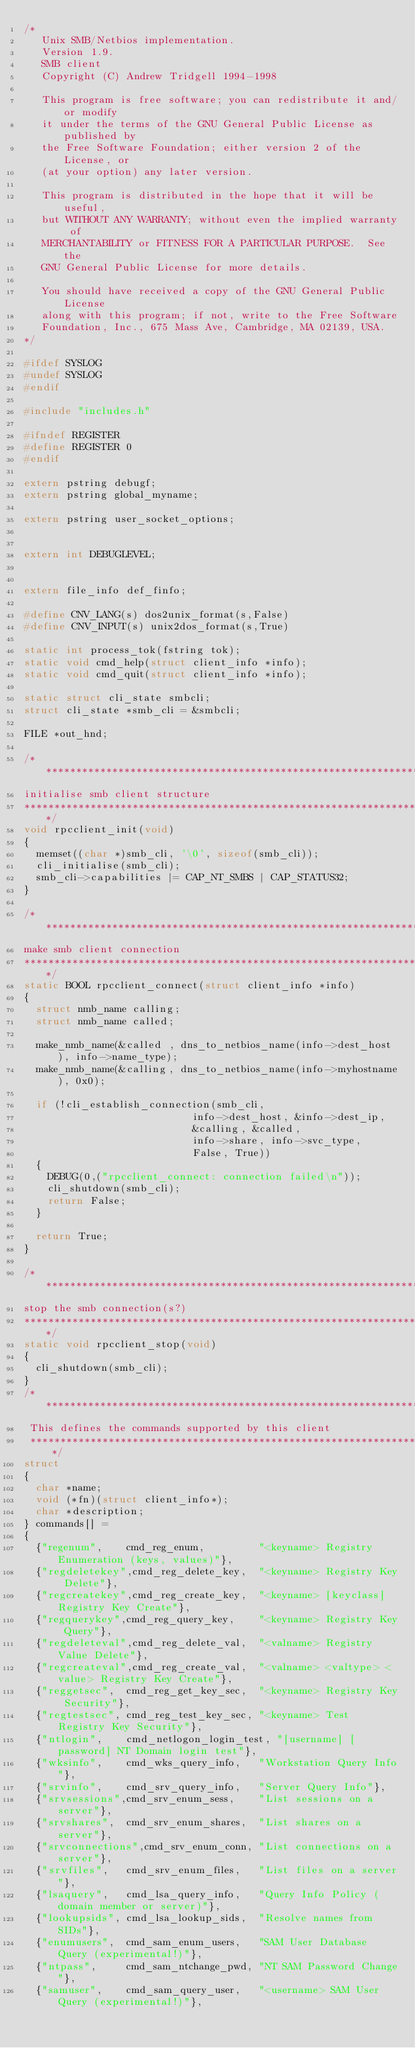<code> <loc_0><loc_0><loc_500><loc_500><_C_>/* 
   Unix SMB/Netbios implementation.
   Version 1.9.
   SMB client
   Copyright (C) Andrew Tridgell 1994-1998
   
   This program is free software; you can redistribute it and/or modify
   it under the terms of the GNU General Public License as published by
   the Free Software Foundation; either version 2 of the License, or
   (at your option) any later version.
   
   This program is distributed in the hope that it will be useful,
   but WITHOUT ANY WARRANTY; without even the implied warranty of
   MERCHANTABILITY or FITNESS FOR A PARTICULAR PURPOSE.  See the
   GNU General Public License for more details.
   
   You should have received a copy of the GNU General Public License
   along with this program; if not, write to the Free Software
   Foundation, Inc., 675 Mass Ave, Cambridge, MA 02139, USA.
*/

#ifdef SYSLOG
#undef SYSLOG
#endif

#include "includes.h"

#ifndef REGISTER
#define REGISTER 0
#endif

extern pstring debugf;
extern pstring global_myname;

extern pstring user_socket_options;


extern int DEBUGLEVEL;


extern file_info def_finfo;

#define CNV_LANG(s) dos2unix_format(s,False)
#define CNV_INPUT(s) unix2dos_format(s,True)

static int process_tok(fstring tok);
static void cmd_help(struct client_info *info);
static void cmd_quit(struct client_info *info);

static struct cli_state smbcli;
struct cli_state *smb_cli = &smbcli;

FILE *out_hnd;

/****************************************************************************
initialise smb client structure
****************************************************************************/
void rpcclient_init(void)
{
	memset((char *)smb_cli, '\0', sizeof(smb_cli));
	cli_initialise(smb_cli);
	smb_cli->capabilities |= CAP_NT_SMBS | CAP_STATUS32;
}

/****************************************************************************
make smb client connection
****************************************************************************/
static BOOL rpcclient_connect(struct client_info *info)
{
	struct nmb_name calling;
	struct nmb_name called;

	make_nmb_name(&called , dns_to_netbios_name(info->dest_host ), info->name_type);
	make_nmb_name(&calling, dns_to_netbios_name(info->myhostname), 0x0);

	if (!cli_establish_connection(smb_cli, 
	                          info->dest_host, &info->dest_ip, 
	                          &calling, &called,
	                          info->share, info->svc_type,
	                          False, True))
	{
		DEBUG(0,("rpcclient_connect: connection failed\n"));
		cli_shutdown(smb_cli);
		return False;
	}

	return True;
}

/****************************************************************************
stop the smb connection(s?)
****************************************************************************/
static void rpcclient_stop(void)
{
	cli_shutdown(smb_cli);
}
/****************************************************************************
 This defines the commands supported by this client
 ****************************************************************************/
struct
{
  char *name;
  void (*fn)(struct client_info*);
  char *description;
} commands[] = 
{
  {"regenum",    cmd_reg_enum,         "<keyname> Registry Enumeration (keys, values)"},
  {"regdeletekey",cmd_reg_delete_key,  "<keyname> Registry Key Delete"},
  {"regcreatekey",cmd_reg_create_key,  "<keyname> [keyclass] Registry Key Create"},
  {"regquerykey",cmd_reg_query_key,    "<keyname> Registry Key Query"},
  {"regdeleteval",cmd_reg_delete_val,  "<valname> Registry Value Delete"},
  {"regcreateval",cmd_reg_create_val,  "<valname> <valtype> <value> Registry Key Create"},
  {"reggetsec",  cmd_reg_get_key_sec,  "<keyname> Registry Key Security"},
  {"regtestsec", cmd_reg_test_key_sec, "<keyname> Test Registry Key Security"},
  {"ntlogin",    cmd_netlogon_login_test, "[username] [password] NT Domain login test"},
  {"wksinfo",    cmd_wks_query_info,   "Workstation Query Info"},
  {"srvinfo",    cmd_srv_query_info,   "Server Query Info"},
  {"srvsessions",cmd_srv_enum_sess,    "List sessions on a server"},
  {"srvshares",  cmd_srv_enum_shares,  "List shares on a server"},
  {"srvconnections",cmd_srv_enum_conn, "List connections on a server"},
  {"srvfiles",   cmd_srv_enum_files,   "List files on a server"},
  {"lsaquery",   cmd_lsa_query_info,   "Query Info Policy (domain member or server)"},
  {"lookupsids", cmd_lsa_lookup_sids,  "Resolve names from SIDs"},
  {"enumusers",  cmd_sam_enum_users,   "SAM User Database Query (experimental!)"},
  {"ntpass",     cmd_sam_ntchange_pwd, "NT SAM Password Change"},
  {"samuser",    cmd_sam_query_user,   "<username> SAM User Query (experimental!)"},</code> 